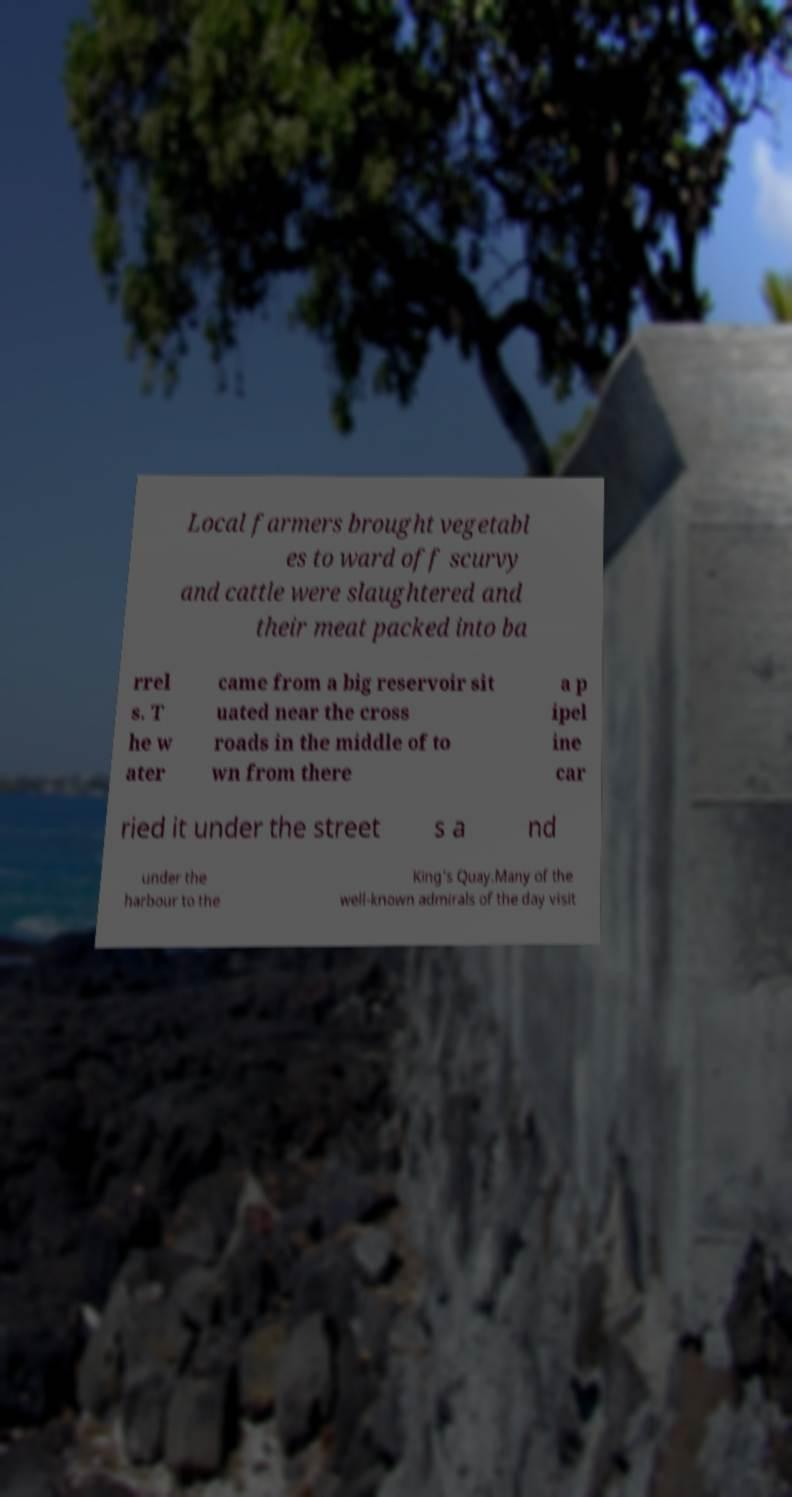What messages or text are displayed in this image? I need them in a readable, typed format. Local farmers brought vegetabl es to ward off scurvy and cattle were slaughtered and their meat packed into ba rrel s. T he w ater came from a big reservoir sit uated near the cross roads in the middle of to wn from there a p ipel ine car ried it under the street s a nd under the harbour to the King's Quay.Many of the well-known admirals of the day visit 